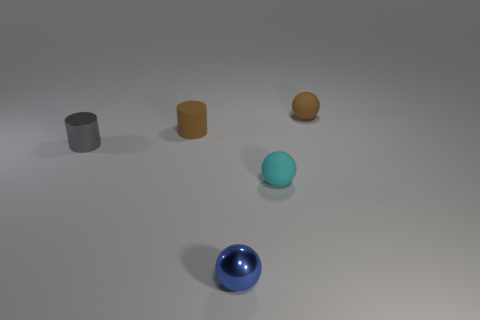There is a cyan ball that is made of the same material as the small brown cylinder; what is its size?
Provide a succinct answer. Small. How many small things are either brown rubber balls or brown cylinders?
Give a very brief answer. 2. There is a metal object that is behind the tiny blue shiny thing that is in front of the metallic thing that is behind the blue ball; what size is it?
Offer a terse response. Small. What number of cyan balls have the same size as the blue object?
Provide a succinct answer. 1. What number of objects are metal cubes or objects that are on the right side of the tiny gray metallic cylinder?
Offer a very short reply. 4. There is a gray metal thing; what shape is it?
Offer a very short reply. Cylinder. Is the matte cylinder the same color as the tiny shiny cylinder?
Keep it short and to the point. No. What is the color of the matte cylinder that is the same size as the blue ball?
Provide a succinct answer. Brown. How many gray objects are small metallic cylinders or big things?
Give a very brief answer. 1. Are there more gray metal cylinders than small cylinders?
Your answer should be compact. No. 